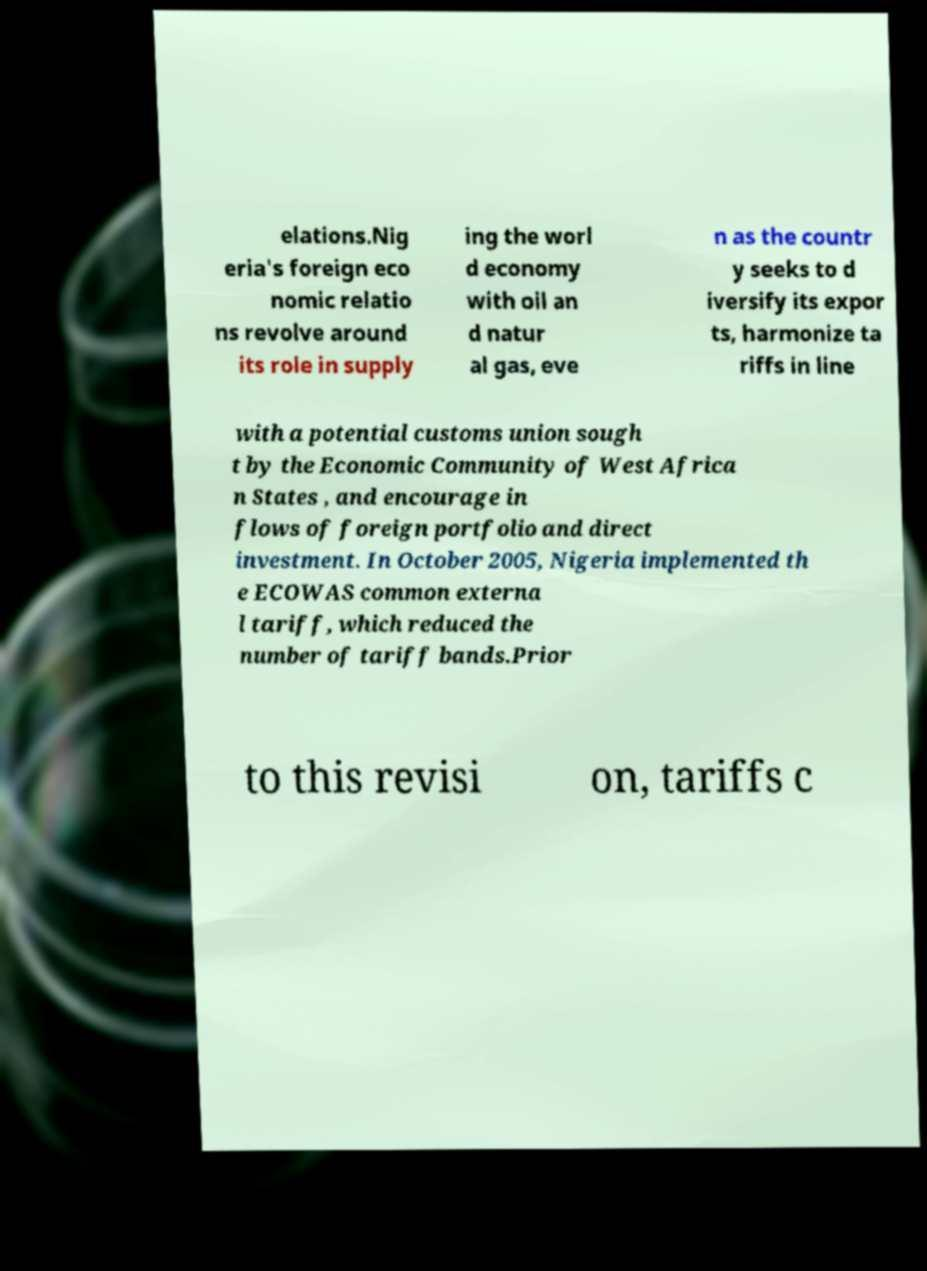For documentation purposes, I need the text within this image transcribed. Could you provide that? elations.Nig eria's foreign eco nomic relatio ns revolve around its role in supply ing the worl d economy with oil an d natur al gas, eve n as the countr y seeks to d iversify its expor ts, harmonize ta riffs in line with a potential customs union sough t by the Economic Community of West Africa n States , and encourage in flows of foreign portfolio and direct investment. In October 2005, Nigeria implemented th e ECOWAS common externa l tariff, which reduced the number of tariff bands.Prior to this revisi on, tariffs c 